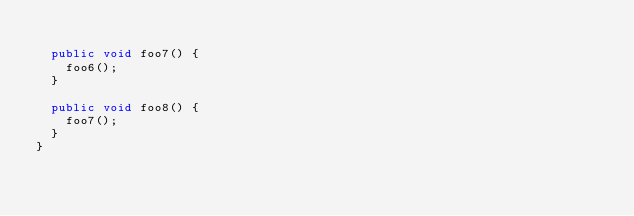<code> <loc_0><loc_0><loc_500><loc_500><_Java_>
  public void foo7() {
    foo6();
  }

  public void foo8() {
    foo7();
  }
}
</code> 